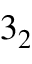Convert formula to latex. <formula><loc_0><loc_0><loc_500><loc_500>3 _ { 2 }</formula> 